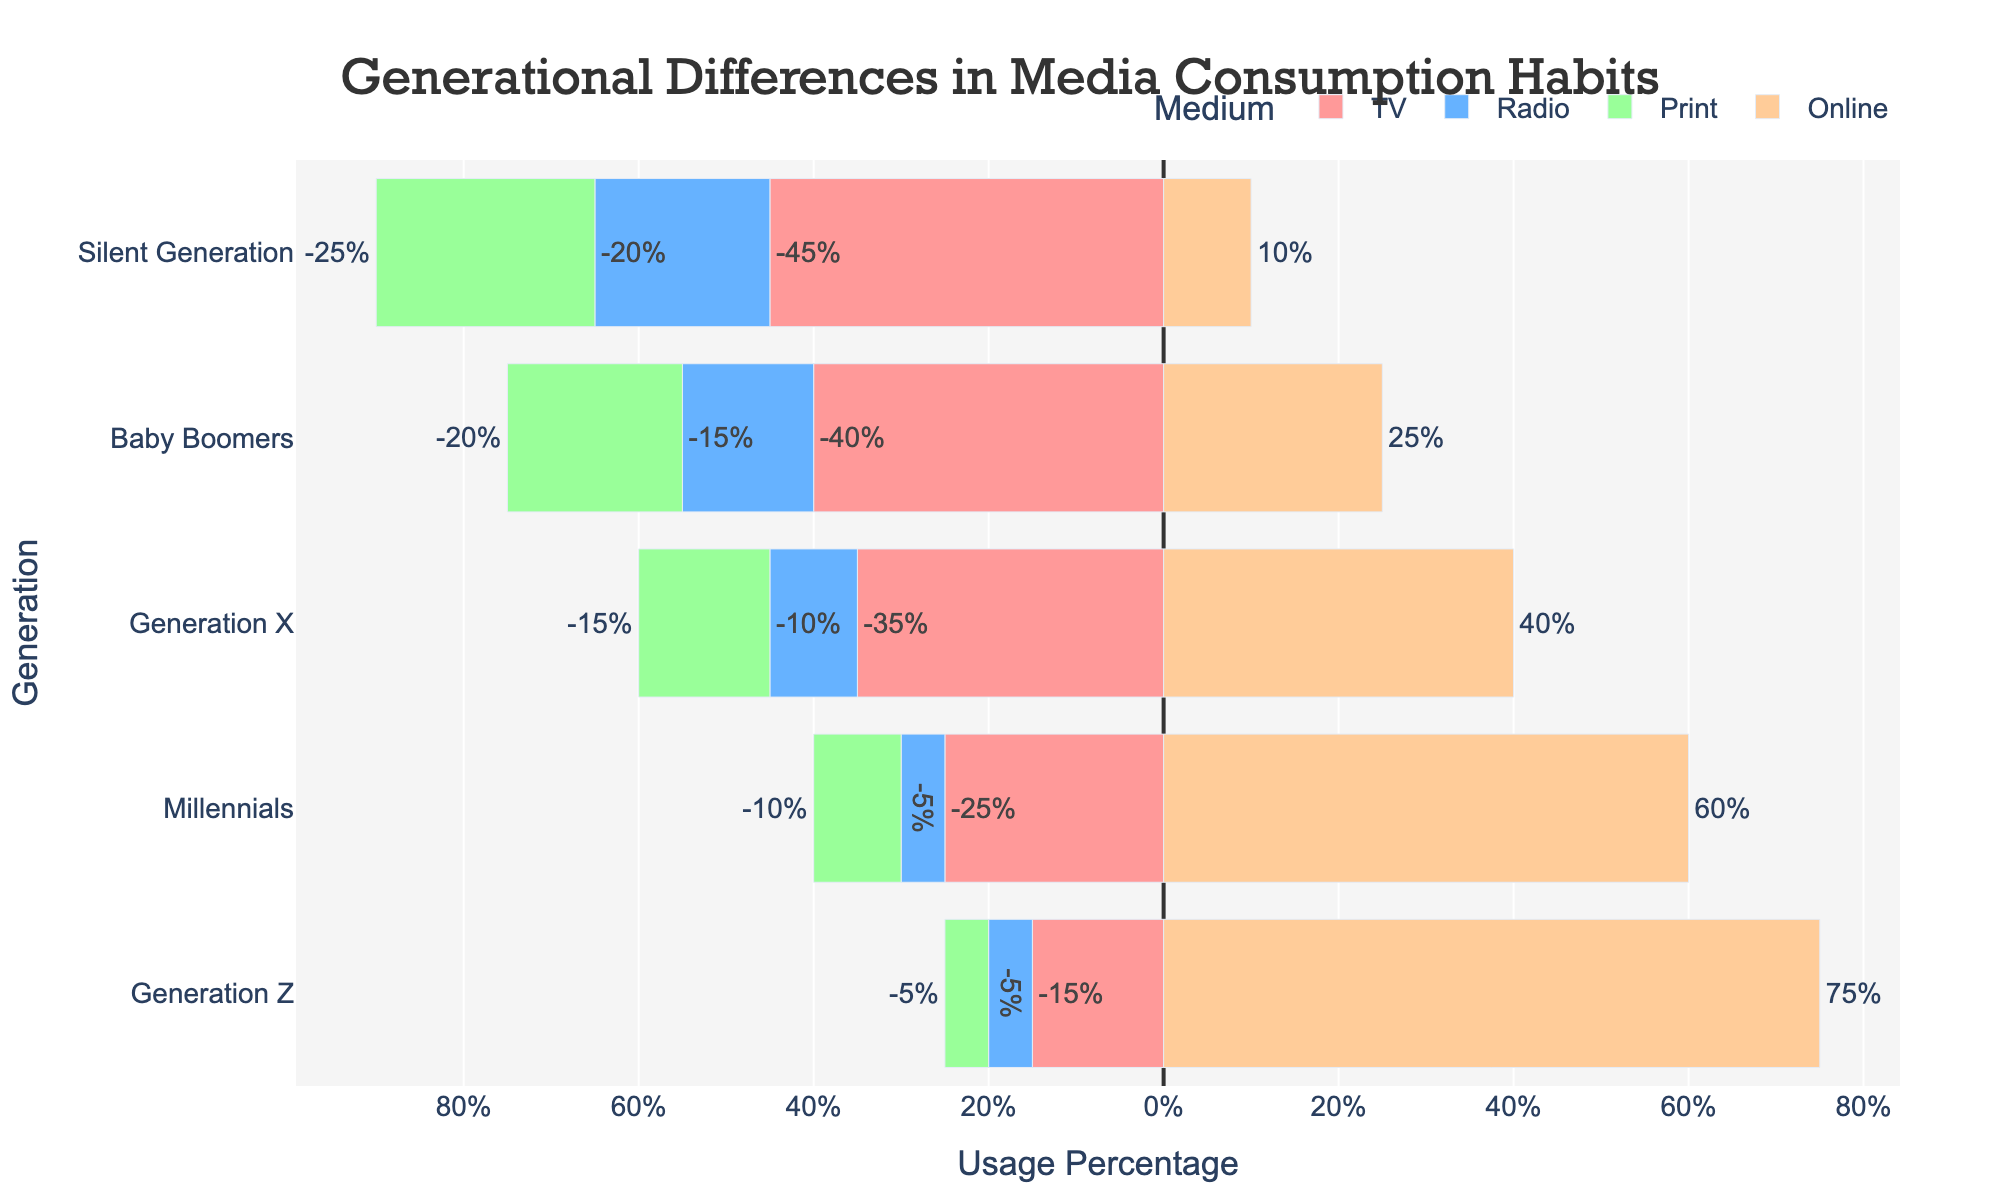What percentage of Millennials consume online media? Look at the bar representing Millennials for the Online medium, which is marked with a brownish color. It extends to the 60% mark on the positive side of the x-axis.
Answer: 60% Which generation uses radio the least? Observe the lengths of the blue bars for each generation for the Radio medium. Generation Z's blue bar is the shortest, indicating a usage of 5%.
Answer: Generation Z How does the percentage of TV consumption by Baby Boomers compare to Generation Z? Compare the lengths of the red bars for TV for Baby Boomers and Generation Z. Baby Boomers have a 40% bar, whereas Generation Z has a 15% bar. So, Baby Boomers have a longer bar by 25%.
Answer: Baby Boomers consume 25% more TV than Generation Z What is the combined percentage of TV and Print consumption for the Silent Generation? Add the lengths of the red and green bars under Silent Generation. TV usage is 45% and Print usage is 25%, so the combined percentage is 45% + 25% = 70%.
Answer: 70% Which medium has the most consistent usage across all generations? Look at the bars of each color across all generations. Radio (blue bars) hovers around the lowest percentage for each generation (5-20%), showing the least variation.
Answer: Radio Which generation primarily consumes online media? Identify the generation with the longest brownish bar for Online medium. Generation Z’s bar is the longest, indicating they primarily consume online media at 75%.
Answer: Generation Z Calculate the difference in Print media consumption between Generation X and Millennials. The green bar shows Print consumption for Generation X at 15% and for Millennials at 10%. The difference is 15% - 10% = 5%.
Answer: 5% Is TV or Print more popular among the Baby Boomers? Compare the lengths of the red bar (TV) and green bar (Print) for Baby Boomers. The bar for TV is longer, with a usage of 40%, while Print has a usage of 20%.
Answer: TV is more popular Which generation consumes the least amount of print media? Look for the shortest green bar in Print media consumption. Generation Z has the shortest bar at 5%.
Answer: Generation Z What percentage of Generation X's media consumption is Online compared to Radio? Compare the brownish bar for Online and blue bar for Radio under Generation X. Online is at 40%, and Radio is at 10%. The Online usage is 30% more than Radio.
Answer: Online is 30% more than Radio 